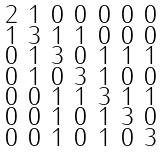<formula> <loc_0><loc_0><loc_500><loc_500>\begin{smallmatrix} 2 & 1 & 0 & 0 & 0 & 0 & 0 \\ 1 & 3 & 1 & 1 & 0 & 0 & 0 \\ 0 & 1 & 3 & 0 & 1 & 1 & 1 \\ 0 & 1 & 0 & 3 & 1 & 0 & 0 \\ 0 & 0 & 1 & 1 & 3 & 1 & 1 \\ 0 & 0 & 1 & 0 & 1 & 3 & 0 \\ 0 & 0 & 1 & 0 & 1 & 0 & 3 \end{smallmatrix}</formula> 